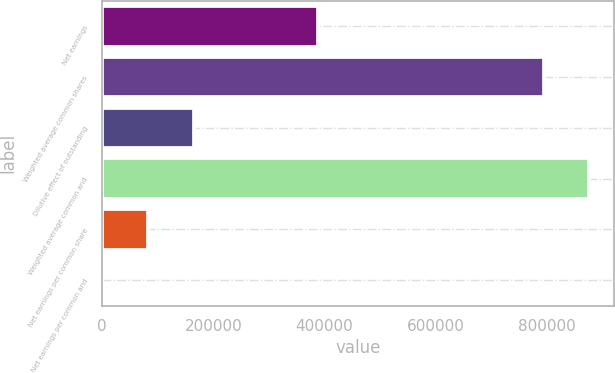Convert chart to OTSL. <chart><loc_0><loc_0><loc_500><loc_500><bar_chart><fcel>Net earnings<fcel>Weighted average common shares<fcel>Dilutive effect of outstanding<fcel>Weighted average common and<fcel>Net earnings per common share<fcel>Net earnings per common and<nl><fcel>388880<fcel>794347<fcel>164586<fcel>876640<fcel>82293.4<fcel>0.47<nl></chart> 